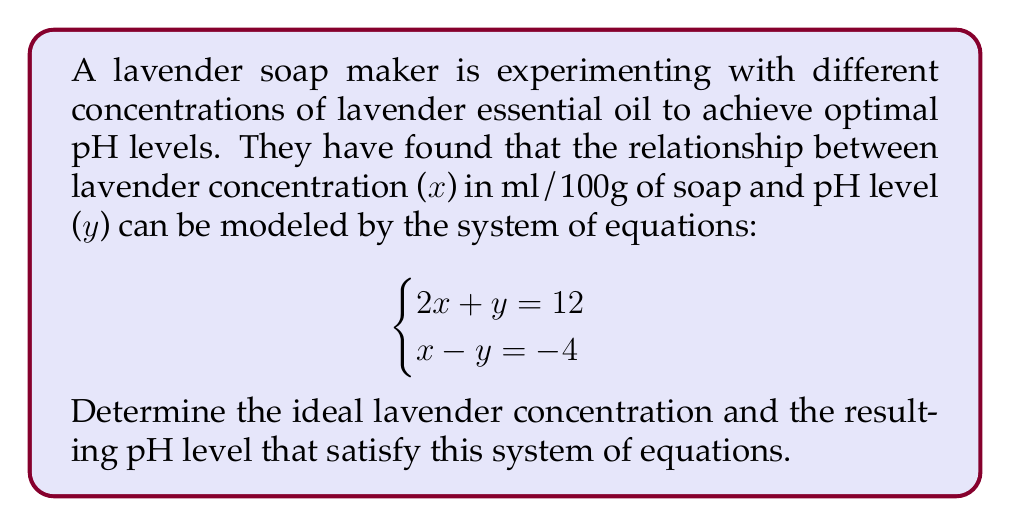Show me your answer to this math problem. To solve this system of equations, we can use the substitution method:

1) From the second equation, we can express y in terms of x:
   $x - y = -4$
   $y = x + 4$

2) Substitute this expression for y into the first equation:
   $2x + (x + 4) = 12$

3) Simplify:
   $3x + 4 = 12$

4) Subtract 4 from both sides:
   $3x = 8$

5) Divide both sides by 3:
   $x = \frac{8}{3} \approx 2.67$

6) Now that we know x, we can find y by substituting x back into either of the original equations. Let's use $y = x + 4$:
   $y = \frac{8}{3} + 4 = \frac{8}{3} + \frac{12}{3} = \frac{20}{3} \approx 6.67$

Therefore, the ideal lavender concentration is approximately 2.67 ml per 100g of soap, resulting in a pH level of about 6.67.
Answer: Lavender concentration: $\frac{8}{3}$ ml/100g of soap (≈ 2.67 ml/100g)
pH level: $\frac{20}{3}$ (≈ 6.67) 